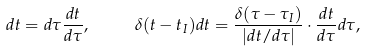<formula> <loc_0><loc_0><loc_500><loc_500>d t = d \tau \frac { d t } { d \tau } , \quad & \quad \delta ( t - t _ { I } ) d t = \frac { \delta ( \tau - \tau _ { I } ) } { | { d t } / { d \tau } | } \cdot \frac { d t } { d \tau } d \tau ,</formula> 